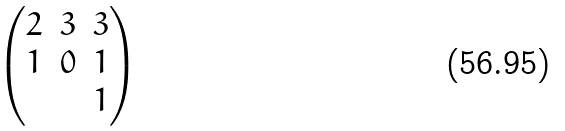<formula> <loc_0><loc_0><loc_500><loc_500>\begin{pmatrix} 2 & 3 & 3 \\ 1 & 0 & 1 \\ & & 1 \end{pmatrix}</formula> 